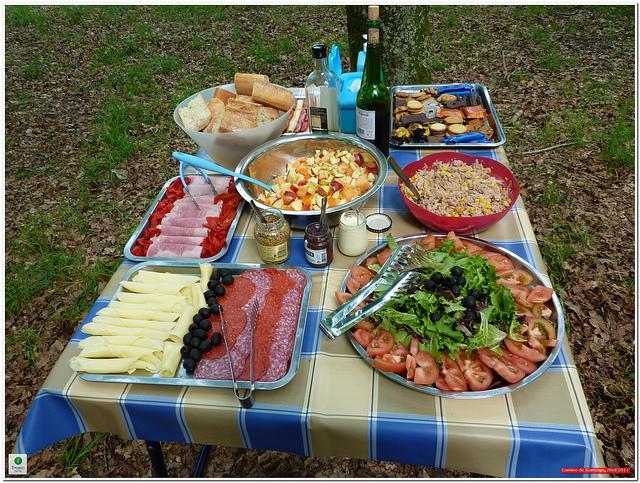What kind of beverage will be served with this food?
Write a very short answer. Wine. How many people is coming to this picnic?
Concise answer only. 8. What kind of meats are served?
Give a very brief answer. Sandwich. 